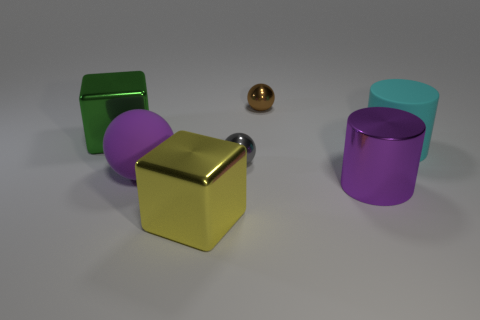Add 2 blocks. How many objects exist? 9 Subtract all cubes. How many objects are left? 5 Subtract all large yellow metal objects. Subtract all blocks. How many objects are left? 4 Add 6 yellow shiny things. How many yellow shiny things are left? 7 Add 4 yellow matte cylinders. How many yellow matte cylinders exist? 4 Subtract 0 yellow balls. How many objects are left? 7 